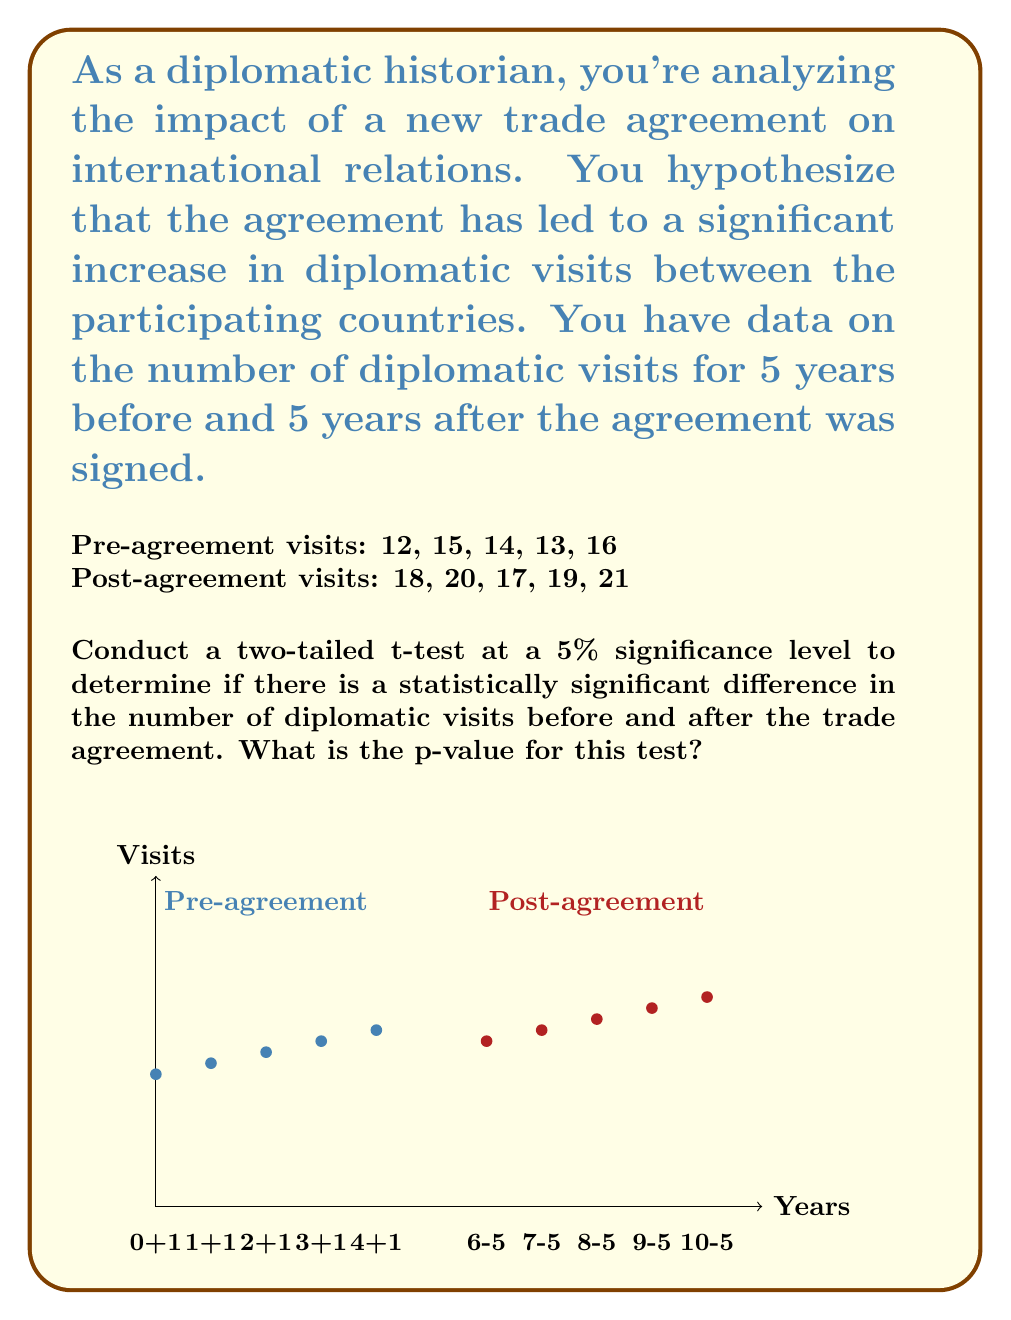Show me your answer to this math problem. To conduct a two-tailed t-test for independent samples, we'll follow these steps:

1) Calculate the means and standard deviations for both groups:

   Pre-agreement: 
   $\bar{x}_1 = \frac{12 + 15 + 14 + 13 + 16}{5} = 14$
   $s_1 = \sqrt{\frac{\sum(x_i - \bar{x}_1)^2}{n_1 - 1}} = 1.58$

   Post-agreement:
   $\bar{x}_2 = \frac{18 + 20 + 17 + 19 + 21}{5} = 19$
   $s_2 = \sqrt{\frac{\sum(x_i - \bar{x}_2)^2}{n_2 - 1}} = 1.58$

2) Calculate the pooled standard deviation:
   $s_p = \sqrt{\frac{(n_1 - 1)s_1^2 + (n_2 - 1)s_2^2}{n_1 + n_2 - 2}}$
   $s_p = \sqrt{\frac{(5-1)(1.58)^2 + (5-1)(1.58)^2}{5 + 5 - 2}} = 1.58$

3) Calculate the t-statistic:
   $t = \frac{\bar{x}_2 - \bar{x}_1}{s_p\sqrt{\frac{2}{n}}}$
   $t = \frac{19 - 14}{1.58\sqrt{\frac{2}{5}}} = 5.03$

4) Degrees of freedom: $df = n_1 + n_2 - 2 = 5 + 5 - 2 = 8$

5) Find the p-value:
   Using a t-distribution table or calculator with 8 degrees of freedom, we find:
   $p\text{-value} = 2 \times P(T > 5.03) \approx 0.001$

The p-value is approximately 0.001, which is less than the significance level of 0.05.
Answer: $p\text{-value} \approx 0.001$ 